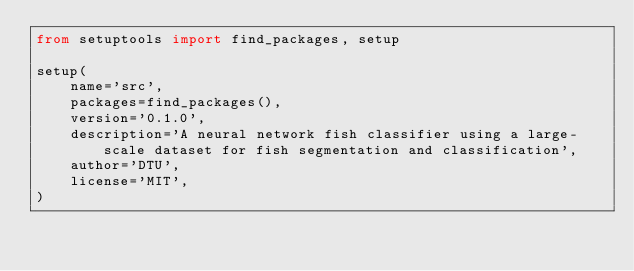Convert code to text. <code><loc_0><loc_0><loc_500><loc_500><_Python_>from setuptools import find_packages, setup

setup(
    name='src',
    packages=find_packages(),
    version='0.1.0',
    description='A neural network fish classifier using a large-scale dataset for fish segmentation and classification',
    author='DTU',
    license='MIT',
)
</code> 